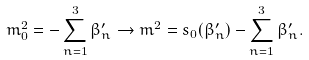Convert formula to latex. <formula><loc_0><loc_0><loc_500><loc_500>m _ { 0 } ^ { 2 } = - \sum _ { n = 1 } ^ { 3 } \beta _ { n } ^ { \prime } \rightarrow m ^ { 2 } = s _ { 0 } ( \beta _ { n } ^ { \prime } ) - \sum _ { n = 1 } ^ { 3 } \beta _ { n } ^ { \prime } .</formula> 